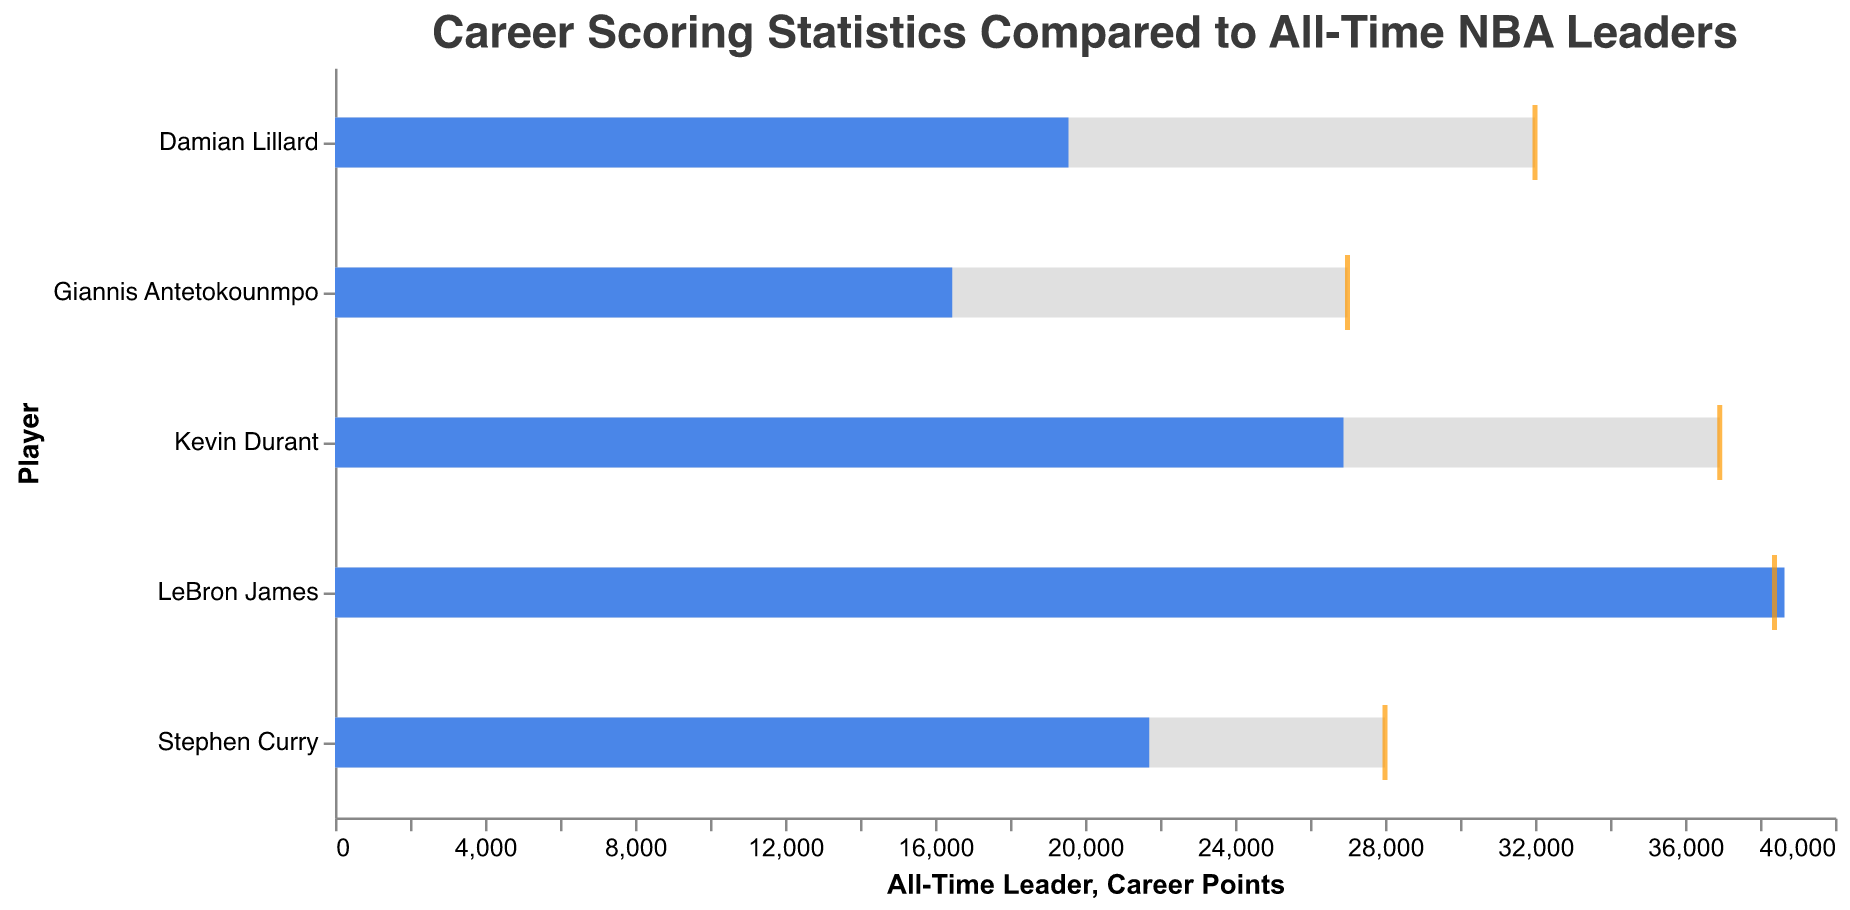What is the title of the chart? The title can be found at the top center of the chart and reads: "Career Scoring Statistics Compared to All-Time NBA Leaders".
Answer: "Career Scoring Statistics Compared to All-Time NBA Leaders" Which player has the highest career points? By looking at the blue bars, LeBron James has the highest career points with 38,652.
Answer: LeBron James How many seasons has Giannis Antetokounmpo played? Giannis Antetokounmpo has played for 10 seasons. This information is found in the data values section corresponding to his name.
Answer: 10 Who is listed as having the 'Top 25%' comparative measure? Damian Lillard is associated with the 'Top 25%' comparative measure in the chart. This is shown next to his name under the Comparative Measure column.
Answer: Damian Lillard Which player has fewer career points than the median of the all-time leaders? The median value of the all-time leaders is 27,000. Both Giannis Antetokounmpo (16,459) and Damian Lillard (19,560) have fewer points than this median.
Answer: Giannis Antetokounmpo and Damian Lillard How does Stephen Curry's career points compare to the average of the all-time leaders? Stephen Curry has 21,712 career points. The average for the all-time leaders is 28,000. Stephen Curry's points are less than the average.
Answer: Less Who has more career points, Kevin Durant or Damian Lillard? By comparing the blue bars, Kevin Durant (26,892) has more career points than Damian Lillard (19,560).
Answer: Kevin Durant What is the difference in career points between the player with the highest and the player with the lowest career points? LeBron James has the highest with 38,652 points, and Giannis Antetokounmpo has the lowest with 16,459 points. The difference is 38,652 - 16,459 = 22,193 points.
Answer: 22,193 points Which player is closest to the all-time leader in points according to the chart? LeBron James, with 38,652 career points, is closest to the all-time leader (38,387 points). This can be observed by comparing the positions of the blue bar and tick marks.
Answer: LeBron James 